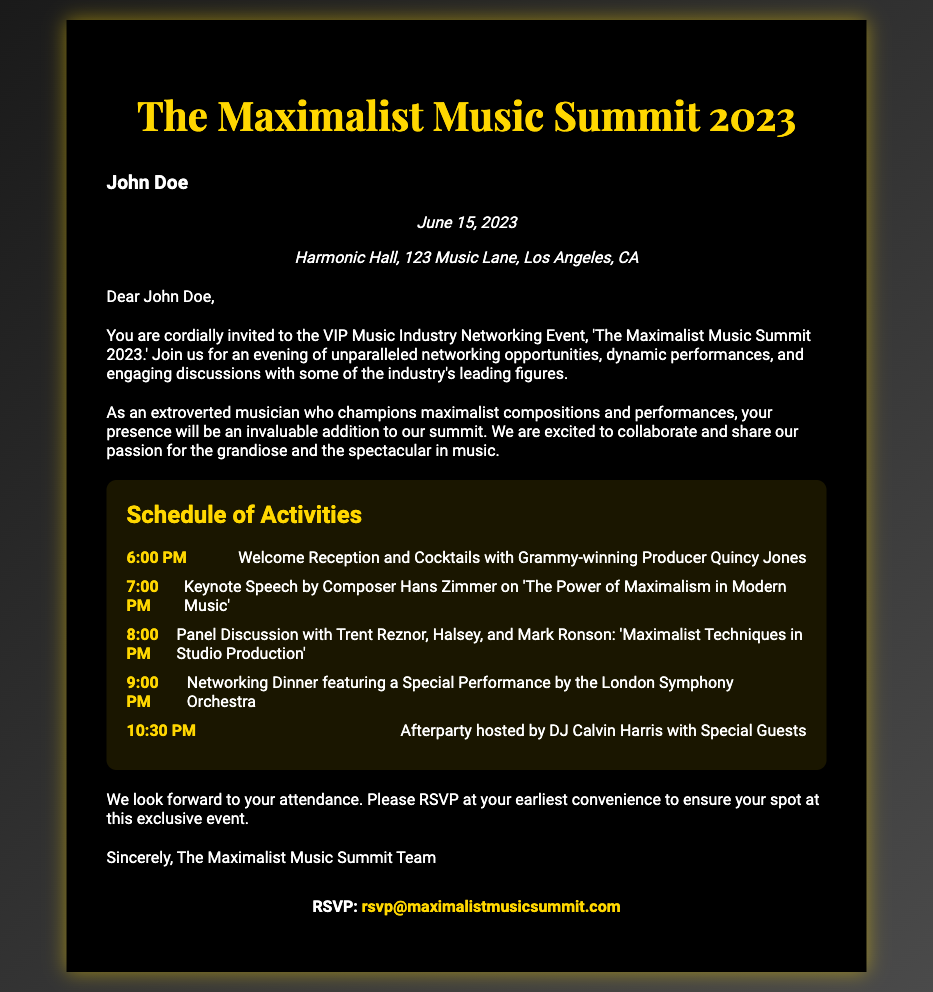What is the date of the event? The date of the event is clearly stated in the document as June 15, 2023.
Answer: June 15, 2023 Who is hosting the afterparty? The document mentions DJ Calvin Harris as the host of the afterparty.
Answer: DJ Calvin Harris What is the location of the event? The location details provided in the document indicate that it is at Harmonic Hall, 123 Music Lane, Los Angeles, CA.
Answer: Harmonic Hall, 123 Music Lane, Los Angeles, CA What is the first activity listed in the schedule? The schedule provides the first activity as "Welcome Reception and Cocktails with Grammy-winning Producer Quincy Jones."
Answer: Welcome Reception and Cocktails with Grammy-winning Producer Quincy Jones How many main activities are listed in the schedule? By counting the activities outlined in the schedule, we find there are five main activities.
Answer: 5 What is the theme of the keynote speech? According to the document, the keynote speech's theme is “The Power of Maximalism in Modern Music.”
Answer: The Power of Maximalism in Modern Music Who can RSVP for the event? The document specifically invites anyone who received the invitation, indicating that the recipient, John Doe, is among those who can RSVP.
Answer: John Doe What is a unique aspect emphasized for John Doe at the event? The document highlights that as an extroverted musician championing maximalist compositions, his presence will be an invaluable addition.
Answer: His presence will be invaluable 